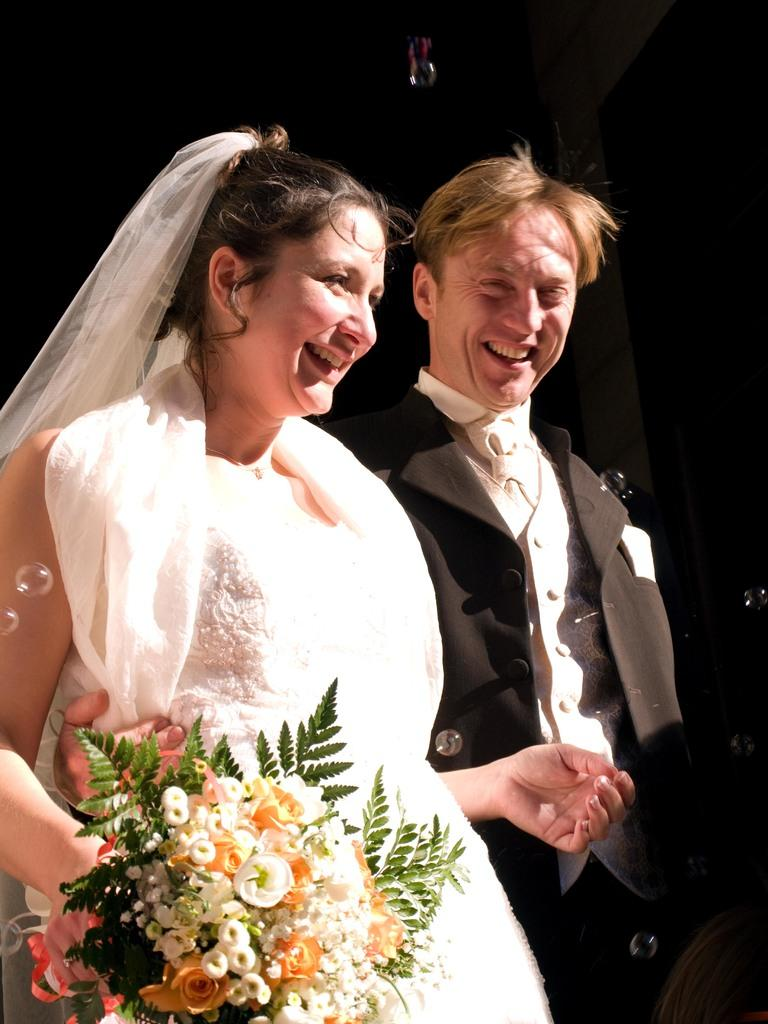What is the man in the image wearing? The man is wearing a black suit. What is the woman in the image wearing? The woman is wearing a white dress. What is the woman holding in the image? The woman is holding a bouquet. What are the facial expressions of the man and the woman in the image? Both the man and the woman are smiling. What are the man and the woman doing in the image? They are both standing. How many boys are flying kites in the image? There are no boys or kites present in the image. 